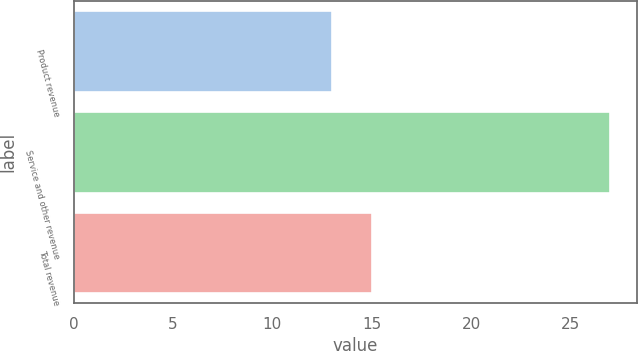Convert chart to OTSL. <chart><loc_0><loc_0><loc_500><loc_500><bar_chart><fcel>Product revenue<fcel>Service and other revenue<fcel>Total revenue<nl><fcel>13<fcel>27<fcel>15<nl></chart> 